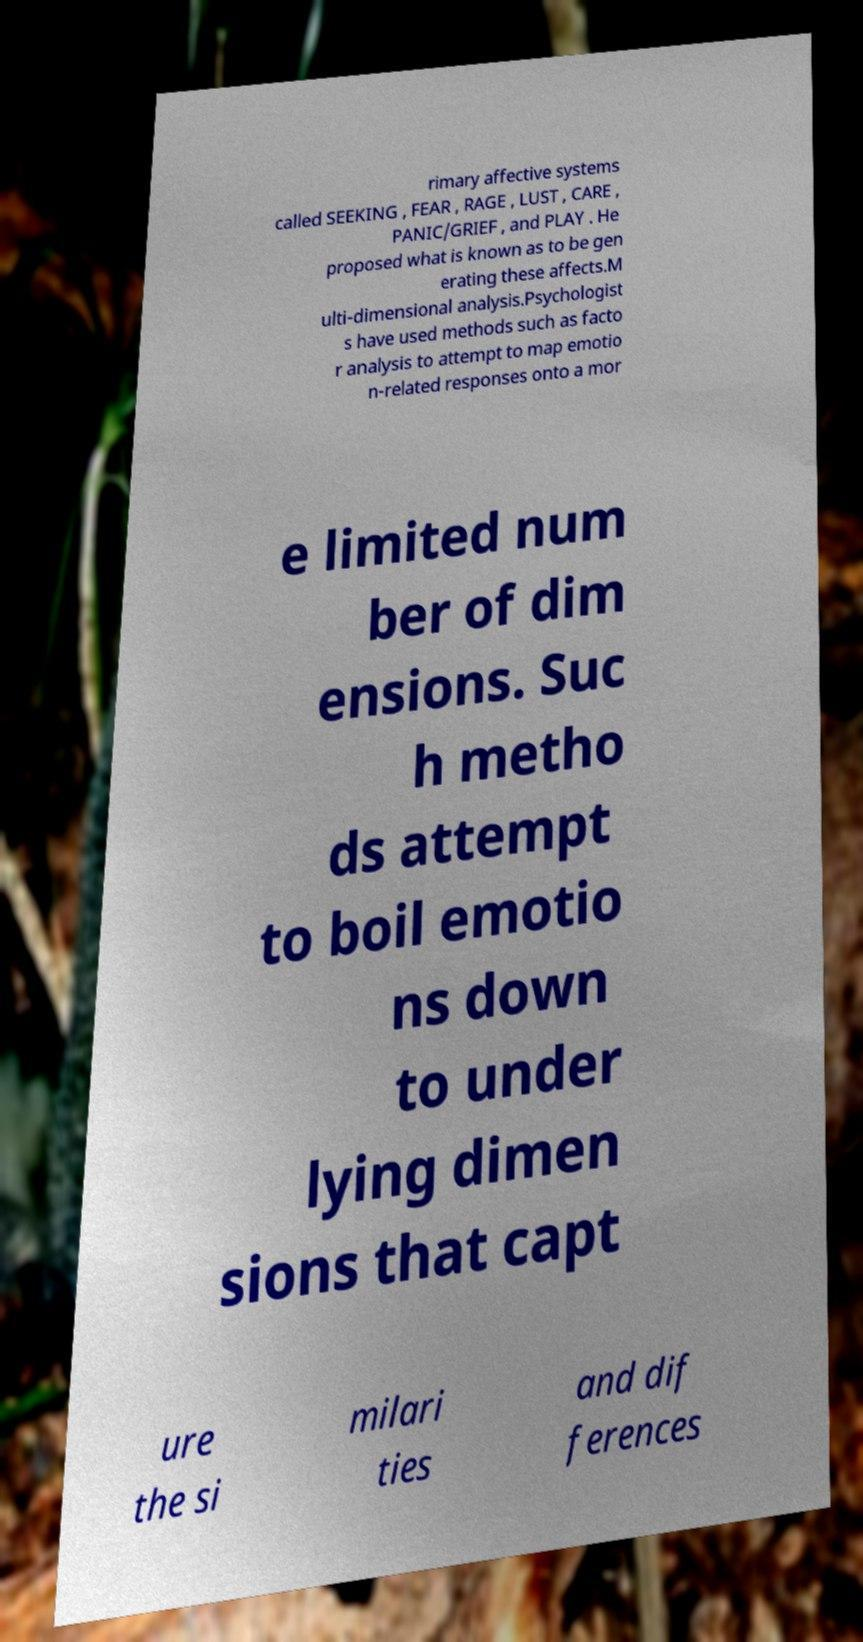Please identify and transcribe the text found in this image. rimary affective systems called SEEKING , FEAR , RAGE , LUST , CARE , PANIC/GRIEF , and PLAY . He proposed what is known as to be gen erating these affects.M ulti-dimensional analysis.Psychologist s have used methods such as facto r analysis to attempt to map emotio n-related responses onto a mor e limited num ber of dim ensions. Suc h metho ds attempt to boil emotio ns down to under lying dimen sions that capt ure the si milari ties and dif ferences 